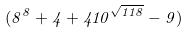<formula> <loc_0><loc_0><loc_500><loc_500>( 8 ^ { 8 } + 4 + 4 1 0 ^ { \sqrt { 1 1 8 } } - 9 )</formula> 